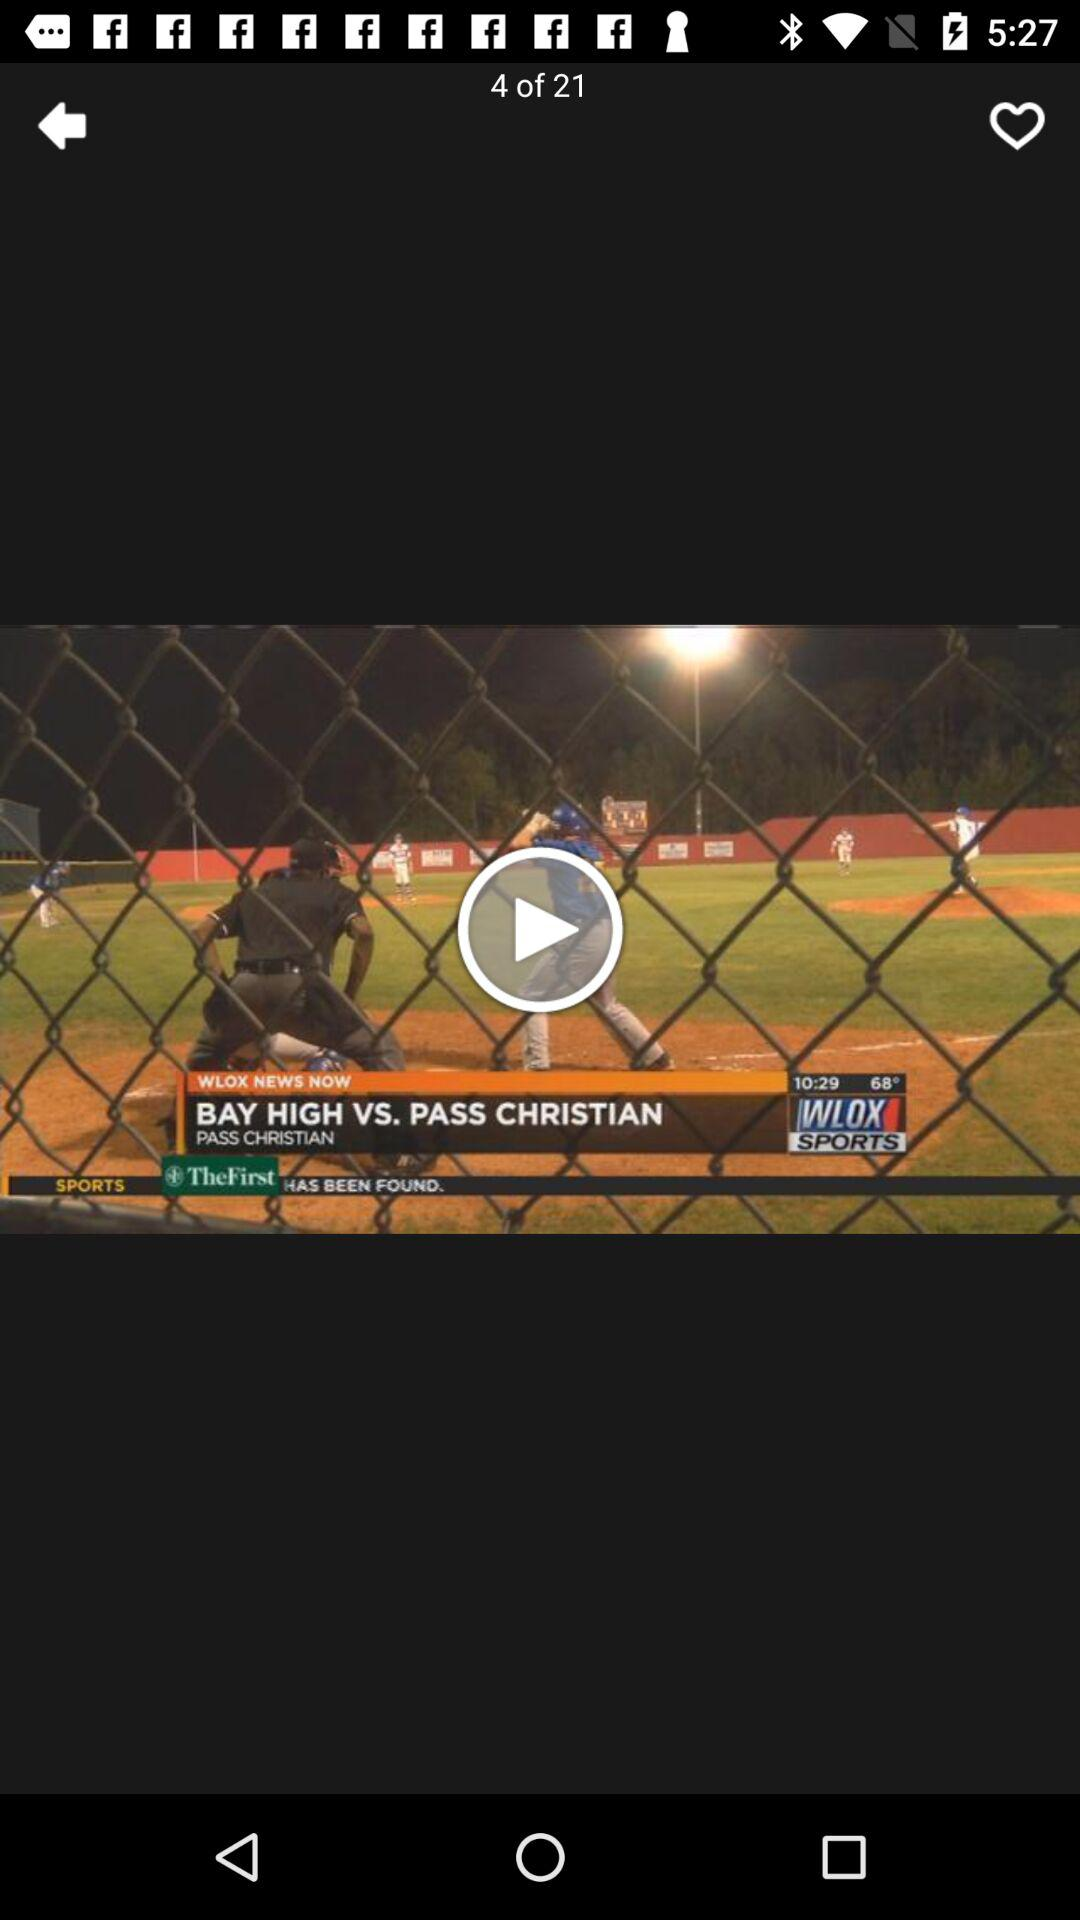On which video am I? You are on the fourth video. 